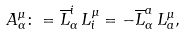<formula> <loc_0><loc_0><loc_500><loc_500>A _ { \alpha } ^ { \mu } \colon = \overline { L } _ { \alpha } ^ { i } \, L _ { i } ^ { \mu } = - \overline { L } _ { \alpha } ^ { a } \, L _ { a } ^ { \mu } ,</formula> 